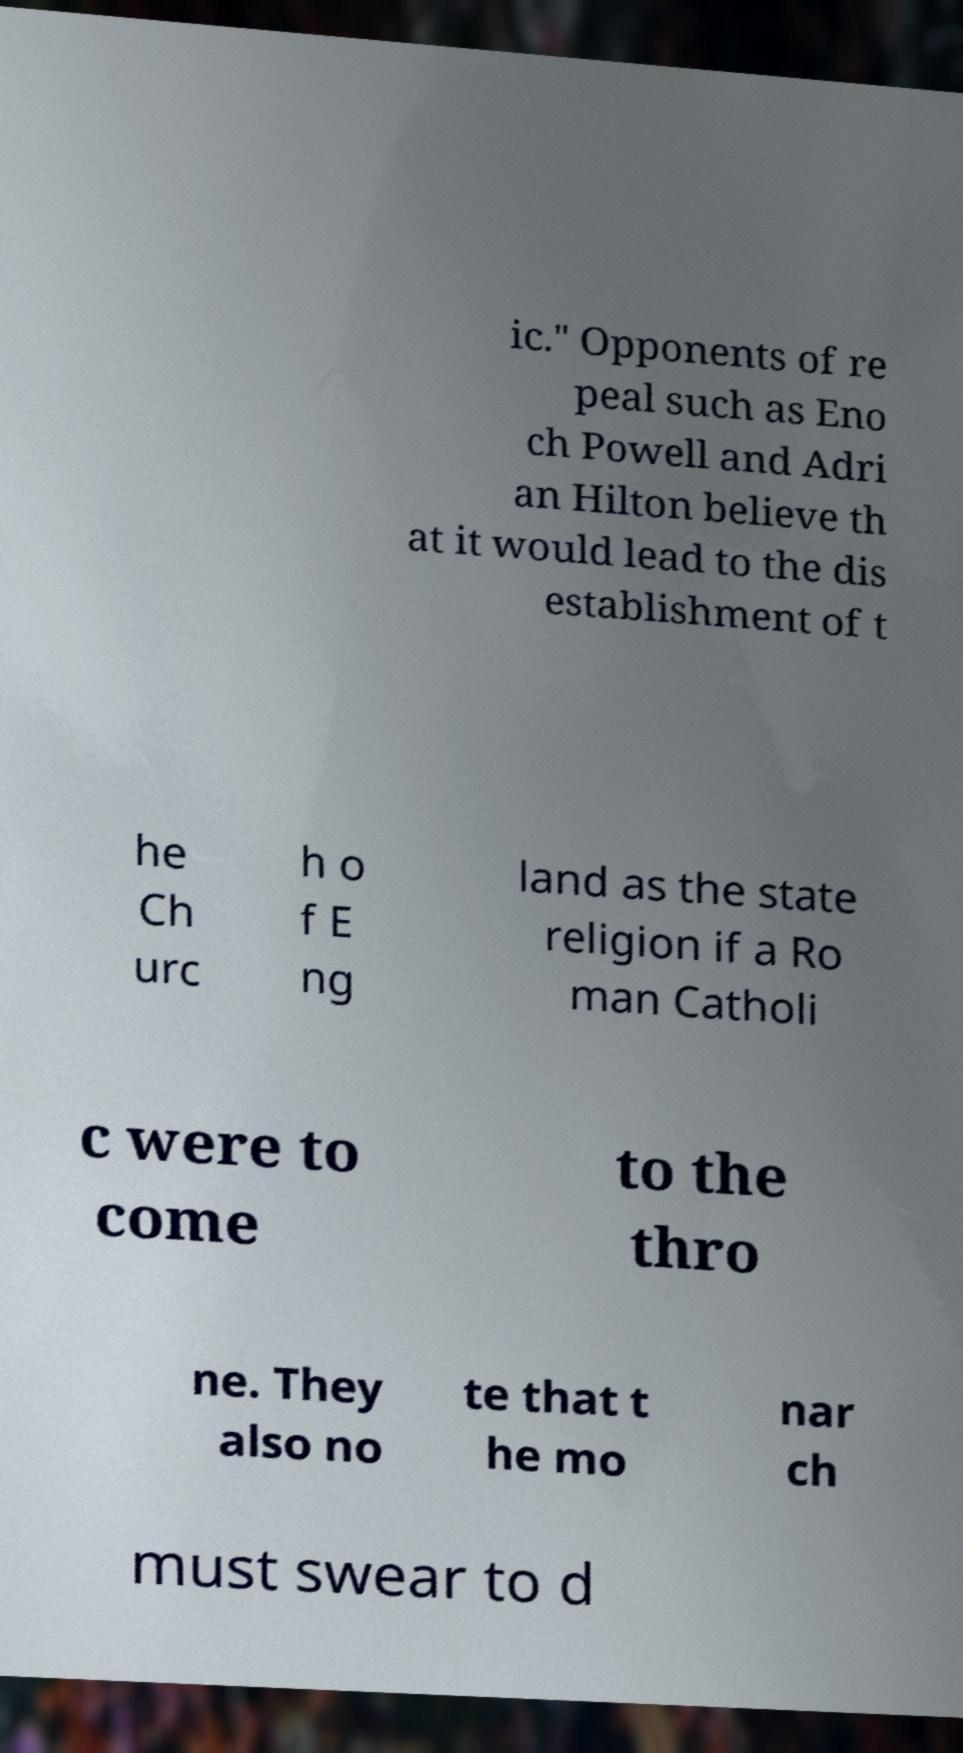For documentation purposes, I need the text within this image transcribed. Could you provide that? ic." Opponents of re peal such as Eno ch Powell and Adri an Hilton believe th at it would lead to the dis establishment of t he Ch urc h o f E ng land as the state religion if a Ro man Catholi c were to come to the thro ne. They also no te that t he mo nar ch must swear to d 